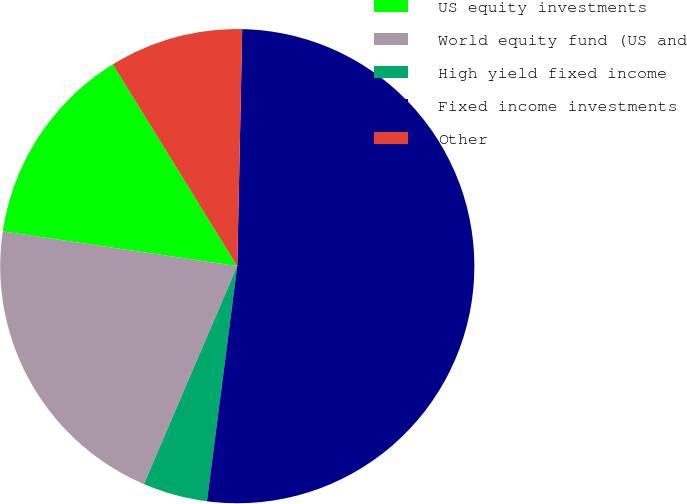Convert chart to OTSL. <chart><loc_0><loc_0><loc_500><loc_500><pie_chart><fcel>US equity investments<fcel>World equity fund (US and<fcel>High yield fixed income<fcel>Fixed income investments<fcel>Other<nl><fcel>13.86%<fcel>20.9%<fcel>4.4%<fcel>51.71%<fcel>9.13%<nl></chart> 